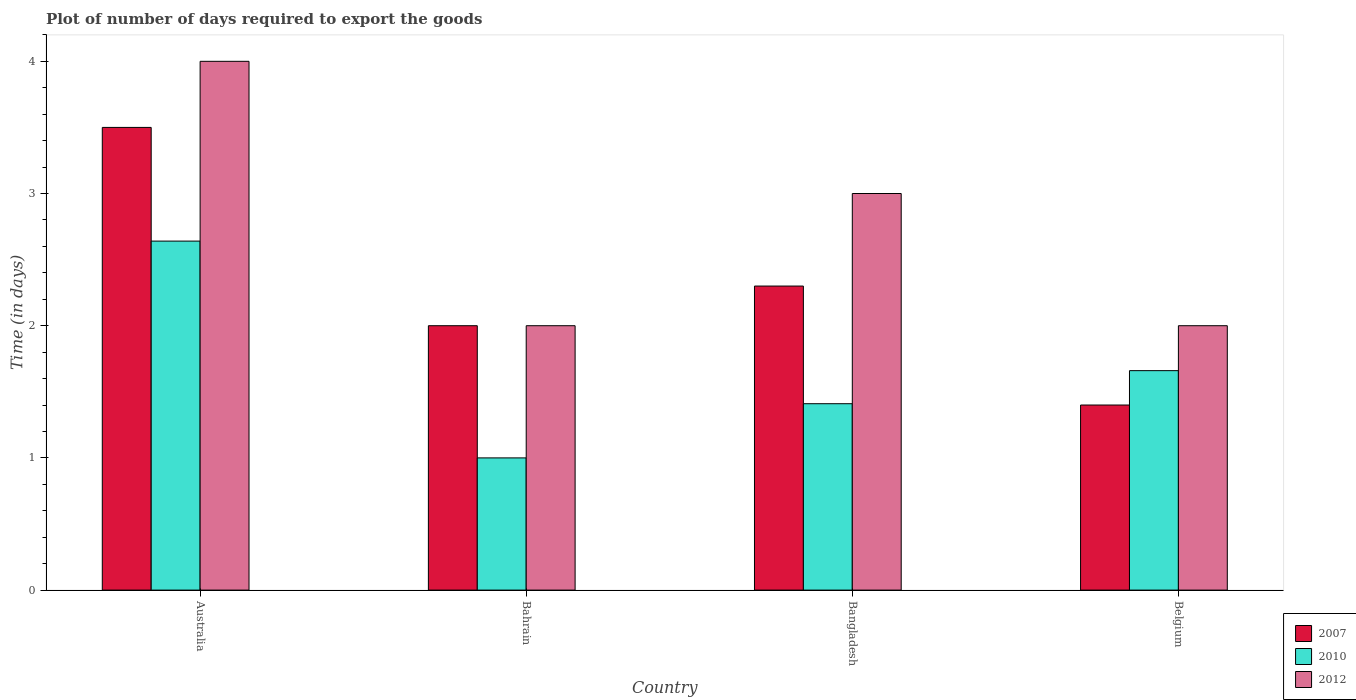How many groups of bars are there?
Ensure brevity in your answer.  4. Are the number of bars per tick equal to the number of legend labels?
Provide a short and direct response. Yes. Are the number of bars on each tick of the X-axis equal?
Your answer should be very brief. Yes. How many bars are there on the 1st tick from the left?
Give a very brief answer. 3. What is the time required to export goods in 2007 in Australia?
Provide a short and direct response. 3.5. In which country was the time required to export goods in 2010 maximum?
Give a very brief answer. Australia. In which country was the time required to export goods in 2010 minimum?
Offer a terse response. Bahrain. What is the total time required to export goods in 2007 in the graph?
Your answer should be compact. 9.2. What is the difference between the time required to export goods in 2007 in Belgium and the time required to export goods in 2010 in Bangladesh?
Provide a succinct answer. -0.01. What is the average time required to export goods in 2010 per country?
Offer a terse response. 1.68. What is the difference between the time required to export goods of/in 2007 and time required to export goods of/in 2012 in Bangladesh?
Your answer should be compact. -0.7. In how many countries, is the time required to export goods in 2010 greater than 1.8 days?
Give a very brief answer. 1. What is the ratio of the time required to export goods in 2012 in Bangladesh to that in Belgium?
Your answer should be very brief. 1.5. What is the difference between the highest and the second highest time required to export goods in 2007?
Provide a succinct answer. -0.3. What is the difference between the highest and the lowest time required to export goods in 2010?
Make the answer very short. 1.64. How many countries are there in the graph?
Your answer should be very brief. 4. Are the values on the major ticks of Y-axis written in scientific E-notation?
Provide a succinct answer. No. Does the graph contain grids?
Provide a short and direct response. No. Where does the legend appear in the graph?
Your response must be concise. Bottom right. How many legend labels are there?
Keep it short and to the point. 3. How are the legend labels stacked?
Your answer should be compact. Vertical. What is the title of the graph?
Offer a terse response. Plot of number of days required to export the goods. What is the label or title of the X-axis?
Give a very brief answer. Country. What is the label or title of the Y-axis?
Give a very brief answer. Time (in days). What is the Time (in days) in 2010 in Australia?
Provide a short and direct response. 2.64. What is the Time (in days) of 2012 in Australia?
Make the answer very short. 4. What is the Time (in days) of 2010 in Bahrain?
Provide a short and direct response. 1. What is the Time (in days) of 2012 in Bahrain?
Make the answer very short. 2. What is the Time (in days) in 2010 in Bangladesh?
Give a very brief answer. 1.41. What is the Time (in days) of 2010 in Belgium?
Keep it short and to the point. 1.66. Across all countries, what is the maximum Time (in days) of 2010?
Provide a short and direct response. 2.64. Across all countries, what is the maximum Time (in days) of 2012?
Offer a very short reply. 4. Across all countries, what is the minimum Time (in days) in 2007?
Provide a succinct answer. 1.4. Across all countries, what is the minimum Time (in days) in 2010?
Provide a short and direct response. 1. What is the total Time (in days) in 2010 in the graph?
Keep it short and to the point. 6.71. What is the difference between the Time (in days) of 2010 in Australia and that in Bahrain?
Your response must be concise. 1.64. What is the difference between the Time (in days) of 2012 in Australia and that in Bahrain?
Offer a terse response. 2. What is the difference between the Time (in days) in 2010 in Australia and that in Bangladesh?
Your answer should be very brief. 1.23. What is the difference between the Time (in days) of 2012 in Australia and that in Bangladesh?
Keep it short and to the point. 1. What is the difference between the Time (in days) of 2010 in Australia and that in Belgium?
Ensure brevity in your answer.  0.98. What is the difference between the Time (in days) of 2007 in Bahrain and that in Bangladesh?
Give a very brief answer. -0.3. What is the difference between the Time (in days) of 2010 in Bahrain and that in Bangladesh?
Your answer should be very brief. -0.41. What is the difference between the Time (in days) of 2007 in Bahrain and that in Belgium?
Keep it short and to the point. 0.6. What is the difference between the Time (in days) of 2010 in Bahrain and that in Belgium?
Ensure brevity in your answer.  -0.66. What is the difference between the Time (in days) of 2010 in Bangladesh and that in Belgium?
Offer a very short reply. -0.25. What is the difference between the Time (in days) of 2012 in Bangladesh and that in Belgium?
Offer a terse response. 1. What is the difference between the Time (in days) in 2007 in Australia and the Time (in days) in 2012 in Bahrain?
Keep it short and to the point. 1.5. What is the difference between the Time (in days) of 2010 in Australia and the Time (in days) of 2012 in Bahrain?
Offer a very short reply. 0.64. What is the difference between the Time (in days) of 2007 in Australia and the Time (in days) of 2010 in Bangladesh?
Provide a succinct answer. 2.09. What is the difference between the Time (in days) in 2010 in Australia and the Time (in days) in 2012 in Bangladesh?
Ensure brevity in your answer.  -0.36. What is the difference between the Time (in days) in 2007 in Australia and the Time (in days) in 2010 in Belgium?
Offer a very short reply. 1.84. What is the difference between the Time (in days) in 2007 in Australia and the Time (in days) in 2012 in Belgium?
Your response must be concise. 1.5. What is the difference between the Time (in days) in 2010 in Australia and the Time (in days) in 2012 in Belgium?
Offer a terse response. 0.64. What is the difference between the Time (in days) of 2007 in Bahrain and the Time (in days) of 2010 in Bangladesh?
Your response must be concise. 0.59. What is the difference between the Time (in days) in 2007 in Bahrain and the Time (in days) in 2010 in Belgium?
Your response must be concise. 0.34. What is the difference between the Time (in days) in 2007 in Bahrain and the Time (in days) in 2012 in Belgium?
Your answer should be very brief. 0. What is the difference between the Time (in days) of 2010 in Bahrain and the Time (in days) of 2012 in Belgium?
Give a very brief answer. -1. What is the difference between the Time (in days) in 2007 in Bangladesh and the Time (in days) in 2010 in Belgium?
Provide a short and direct response. 0.64. What is the difference between the Time (in days) of 2007 in Bangladesh and the Time (in days) of 2012 in Belgium?
Provide a succinct answer. 0.3. What is the difference between the Time (in days) of 2010 in Bangladesh and the Time (in days) of 2012 in Belgium?
Offer a very short reply. -0.59. What is the average Time (in days) of 2010 per country?
Ensure brevity in your answer.  1.68. What is the average Time (in days) of 2012 per country?
Provide a succinct answer. 2.75. What is the difference between the Time (in days) of 2007 and Time (in days) of 2010 in Australia?
Give a very brief answer. 0.86. What is the difference between the Time (in days) in 2010 and Time (in days) in 2012 in Australia?
Ensure brevity in your answer.  -1.36. What is the difference between the Time (in days) of 2007 and Time (in days) of 2010 in Bahrain?
Make the answer very short. 1. What is the difference between the Time (in days) in 2007 and Time (in days) in 2012 in Bahrain?
Your answer should be very brief. 0. What is the difference between the Time (in days) of 2007 and Time (in days) of 2010 in Bangladesh?
Your response must be concise. 0.89. What is the difference between the Time (in days) of 2007 and Time (in days) of 2012 in Bangladesh?
Keep it short and to the point. -0.7. What is the difference between the Time (in days) in 2010 and Time (in days) in 2012 in Bangladesh?
Ensure brevity in your answer.  -1.59. What is the difference between the Time (in days) of 2007 and Time (in days) of 2010 in Belgium?
Your answer should be very brief. -0.26. What is the difference between the Time (in days) of 2007 and Time (in days) of 2012 in Belgium?
Offer a terse response. -0.6. What is the difference between the Time (in days) of 2010 and Time (in days) of 2012 in Belgium?
Provide a short and direct response. -0.34. What is the ratio of the Time (in days) in 2010 in Australia to that in Bahrain?
Offer a terse response. 2.64. What is the ratio of the Time (in days) of 2012 in Australia to that in Bahrain?
Your answer should be compact. 2. What is the ratio of the Time (in days) of 2007 in Australia to that in Bangladesh?
Keep it short and to the point. 1.52. What is the ratio of the Time (in days) in 2010 in Australia to that in Bangladesh?
Make the answer very short. 1.87. What is the ratio of the Time (in days) of 2010 in Australia to that in Belgium?
Keep it short and to the point. 1.59. What is the ratio of the Time (in days) in 2007 in Bahrain to that in Bangladesh?
Keep it short and to the point. 0.87. What is the ratio of the Time (in days) of 2010 in Bahrain to that in Bangladesh?
Offer a very short reply. 0.71. What is the ratio of the Time (in days) of 2012 in Bahrain to that in Bangladesh?
Provide a short and direct response. 0.67. What is the ratio of the Time (in days) of 2007 in Bahrain to that in Belgium?
Your answer should be compact. 1.43. What is the ratio of the Time (in days) in 2010 in Bahrain to that in Belgium?
Your answer should be compact. 0.6. What is the ratio of the Time (in days) in 2012 in Bahrain to that in Belgium?
Provide a succinct answer. 1. What is the ratio of the Time (in days) of 2007 in Bangladesh to that in Belgium?
Ensure brevity in your answer.  1.64. What is the ratio of the Time (in days) of 2010 in Bangladesh to that in Belgium?
Provide a short and direct response. 0.85. What is the ratio of the Time (in days) of 2012 in Bangladesh to that in Belgium?
Your answer should be compact. 1.5. What is the difference between the highest and the second highest Time (in days) of 2012?
Offer a terse response. 1. What is the difference between the highest and the lowest Time (in days) of 2007?
Keep it short and to the point. 2.1. What is the difference between the highest and the lowest Time (in days) in 2010?
Keep it short and to the point. 1.64. What is the difference between the highest and the lowest Time (in days) of 2012?
Offer a terse response. 2. 